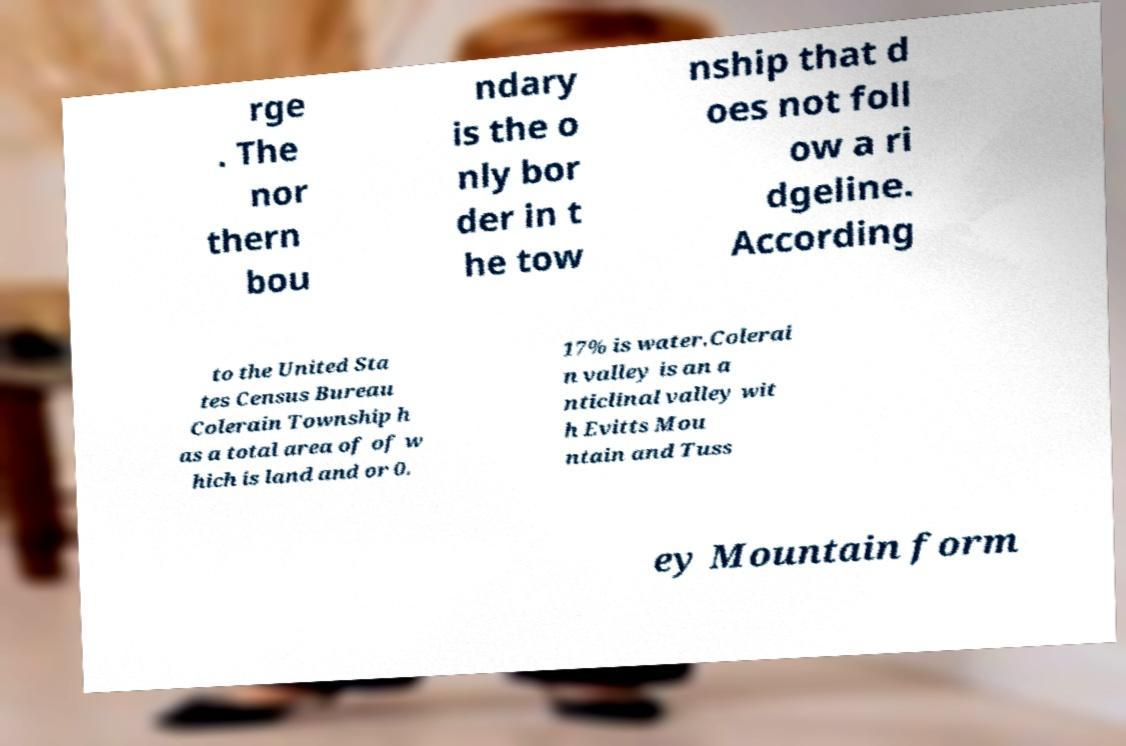Could you assist in decoding the text presented in this image and type it out clearly? rge . The nor thern bou ndary is the o nly bor der in t he tow nship that d oes not foll ow a ri dgeline. According to the United Sta tes Census Bureau Colerain Township h as a total area of of w hich is land and or 0. 17% is water.Colerai n valley is an a nticlinal valley wit h Evitts Mou ntain and Tuss ey Mountain form 